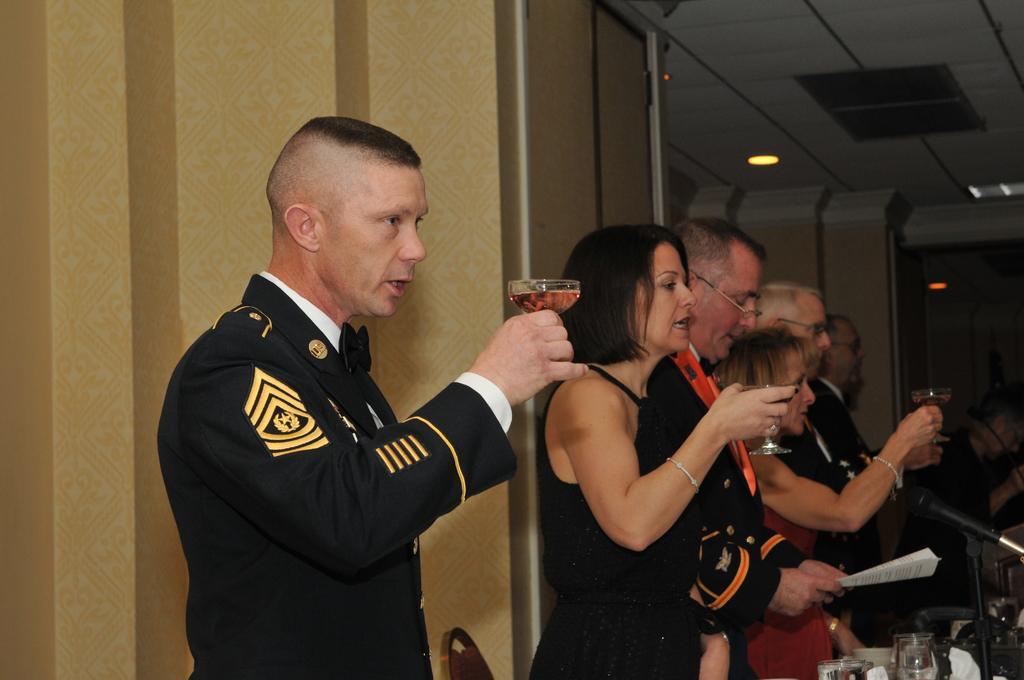Describe this image in one or two sentences. In this image we can see a few people standing and holding drink glasses, we can see the microphone, wall, ceiling with the lights. 